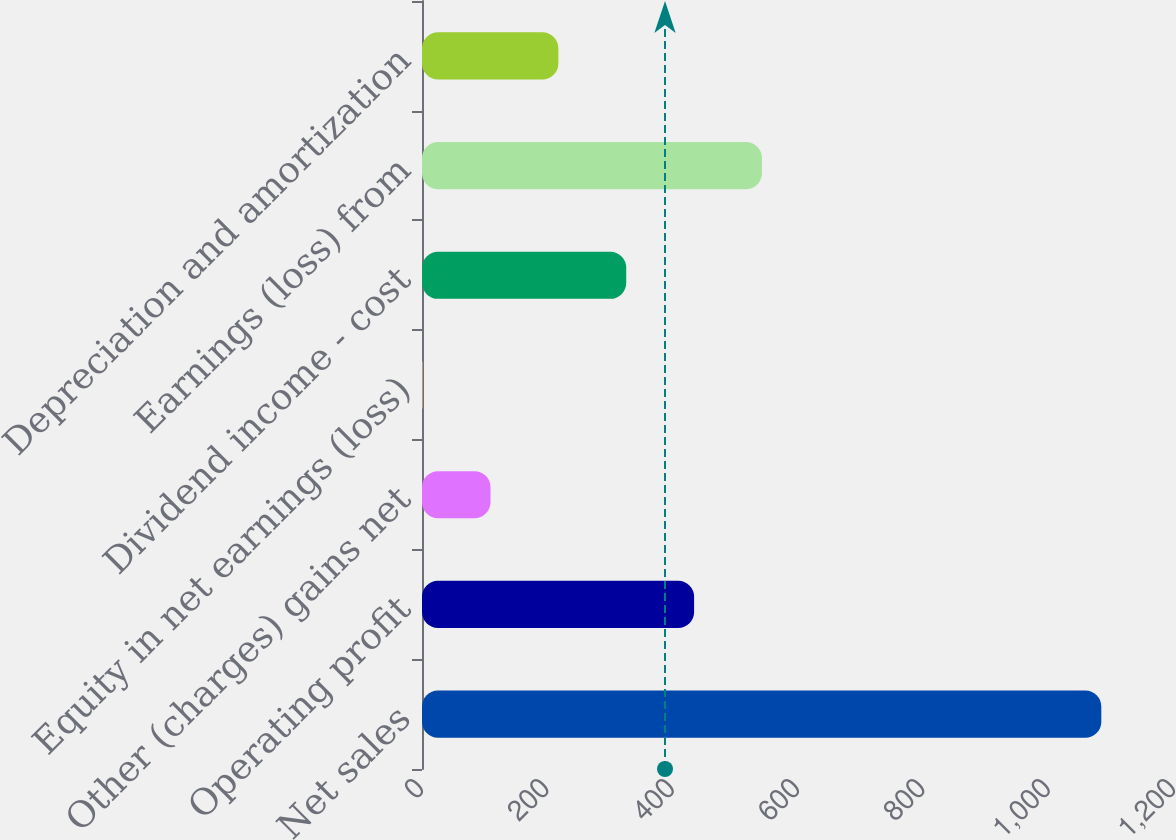Convert chart. <chart><loc_0><loc_0><loc_500><loc_500><bar_chart><fcel>Net sales<fcel>Operating profit<fcel>Other (charges) gains net<fcel>Equity in net earnings (loss)<fcel>Dividend income - cost<fcel>Earnings (loss) from<fcel>Depreciation and amortization<nl><fcel>1084<fcel>434.2<fcel>109.3<fcel>1<fcel>325.9<fcel>542.5<fcel>217.6<nl></chart> 